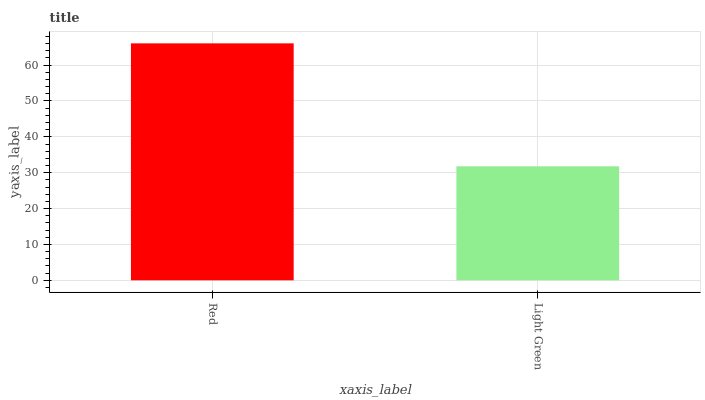Is Light Green the maximum?
Answer yes or no. No. Is Red greater than Light Green?
Answer yes or no. Yes. Is Light Green less than Red?
Answer yes or no. Yes. Is Light Green greater than Red?
Answer yes or no. No. Is Red less than Light Green?
Answer yes or no. No. Is Red the high median?
Answer yes or no. Yes. Is Light Green the low median?
Answer yes or no. Yes. Is Light Green the high median?
Answer yes or no. No. Is Red the low median?
Answer yes or no. No. 